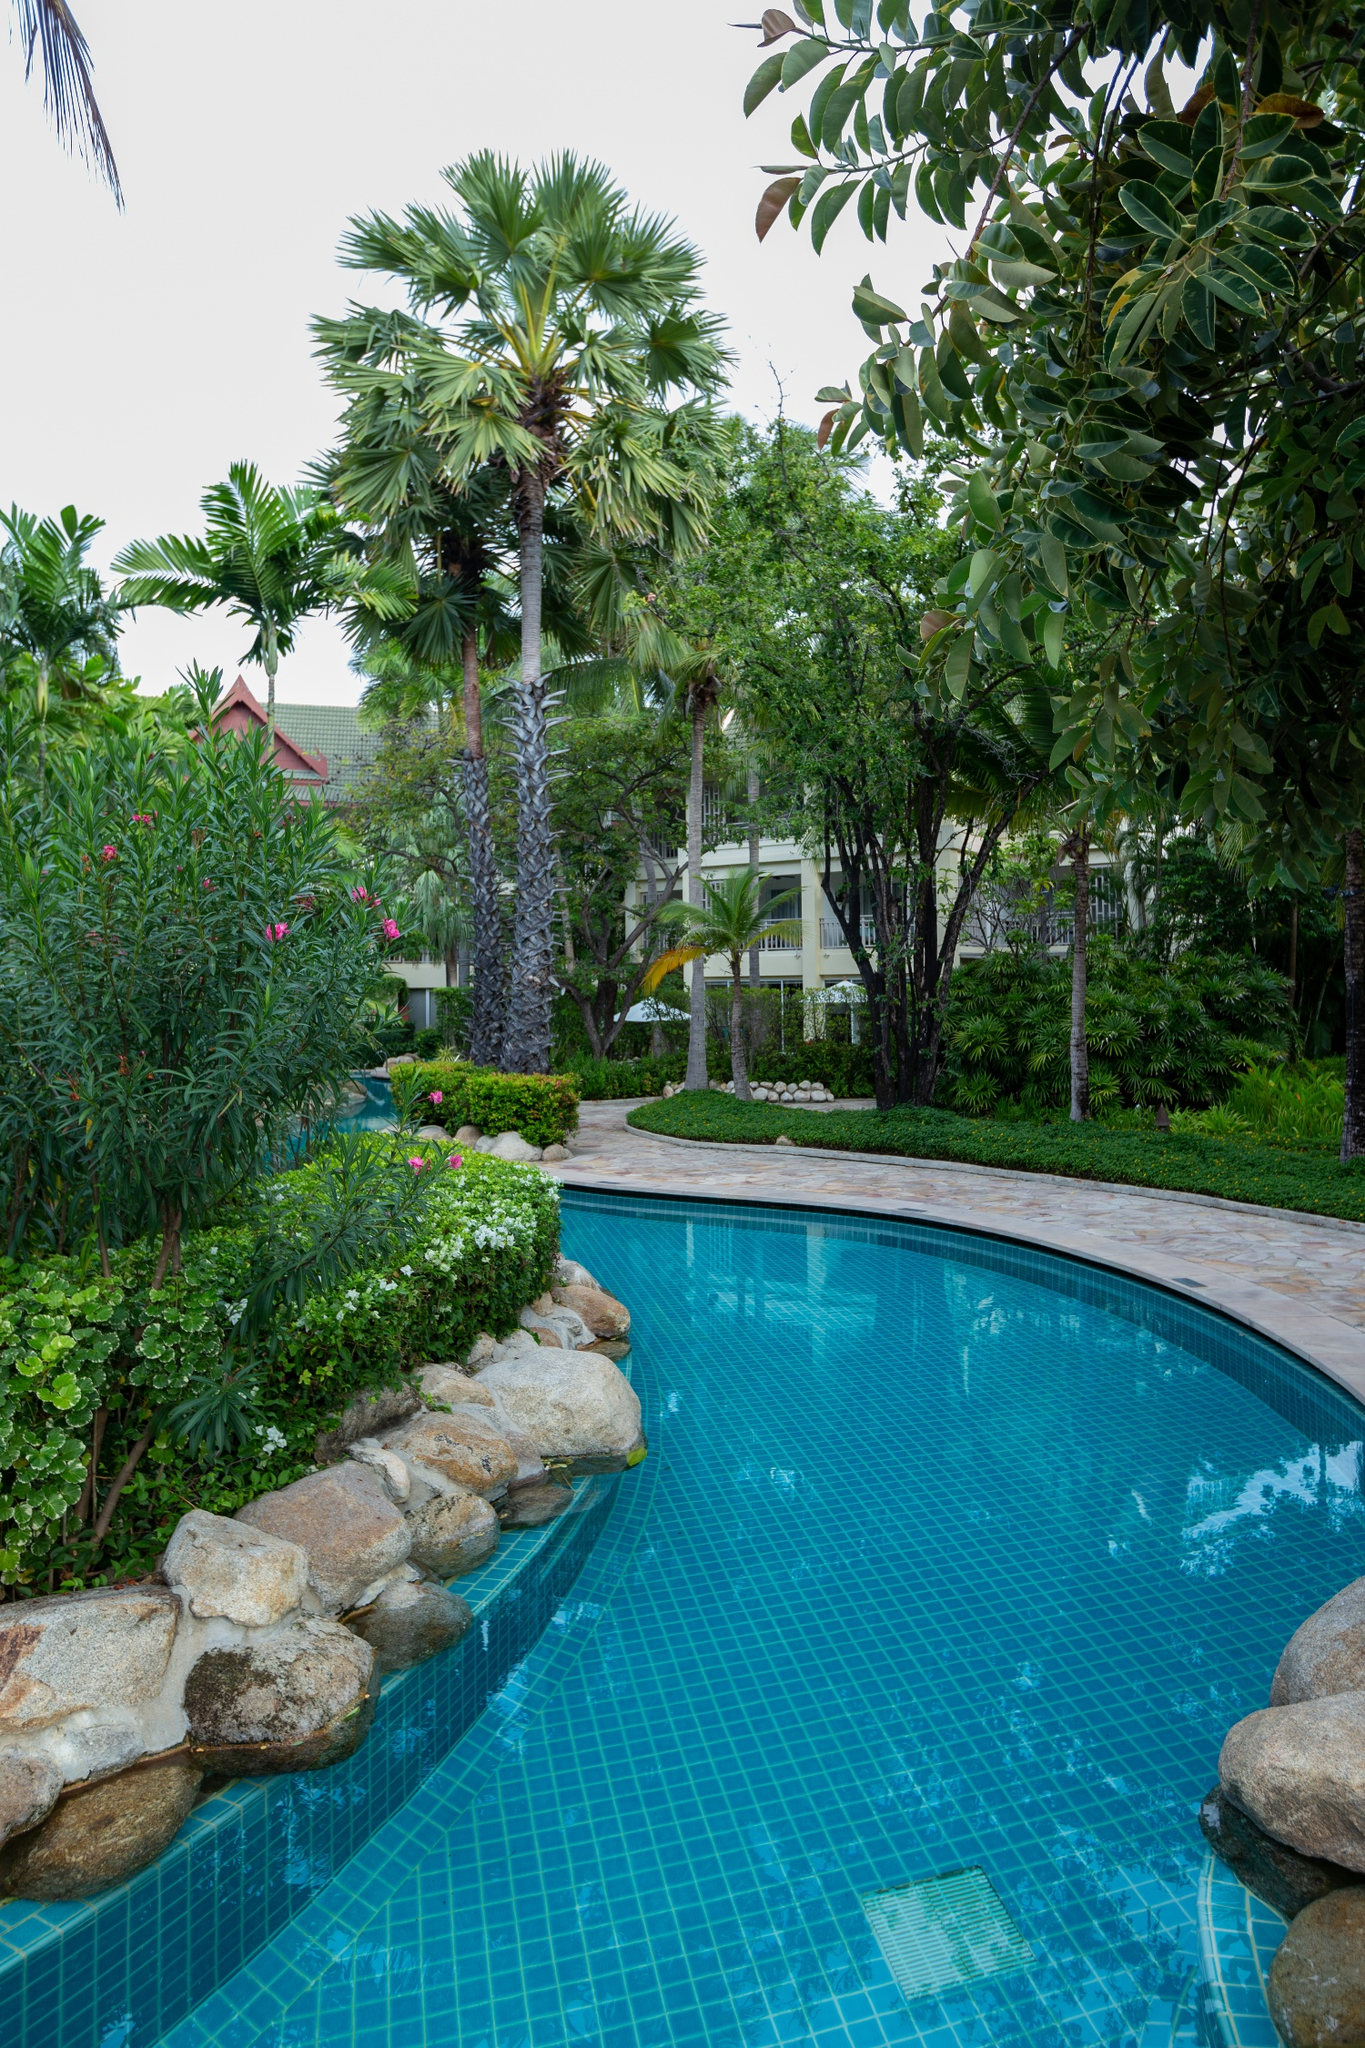Can you craft a creative story based on this image? In a secluded corner of the world, there existed an enchanted garden known only to a select few adventurers. The centerpiece of this magical realm was a pristine, curving swimming pool with waters so clear, they mirrored the sky’s azure hues. Legend had it that the pool was home to a gentle water spirit who blessed the grounds with eternal tranquility and lush greenery. Majestic palm trees whispered secrets of the ancient times, while flowers of every color bloomed vibrantly, fed by the spirit’s nurturing presence. Among the garden’s visitors was Serena, a young explorer with a heart full of dreams. Drawn by tales of the enchanted garden, she embarked on a journey to find it. Upon arrival, Serena felt the warm embrace of peace as the water spirit’s blessings enveloped her. She spent days exploring every nook and cranny of the garden, discovering hidden groves where time seemed to stand still. By night, the white building in the background transformed into a mystical castle, shimmering under the moonlight, revealing Serena’s true quest: to unlock the secret of the enchanted pool. With the spirit’s guidance, she would one day uncover a hidden underwater world brimming with untold stories and adventures, forever changing her destiny. What might the guests enjoy most during an evening at this resort? As the sun begins to set, casting golden hues across the pool and garden, guests at this idyllic resort transition from bustling daytime activities to serene evening indulgences. One of the highlights of the evening is dining al fresco by the poolside, where the gentle sound of water lapping against the rocks accompanies a gourmet meal. As twilight descends, the garden comes alive with the soft glow of lanterns and fairy lights, creating an enchanting ambiance. Guests can savor fine wines and cocktails from the bar, engaging in pleasant conversations or simply soaking in the tranquil surroundings. For those seeking relaxation, an evening swim in the illuminated pool offers a magical experience, with the stars reflecting off the water’s surface. Alternatively, the resort may offer entertainment like live music or cultural performances, giving guests a taste of the local heritage. Ultimately, the evening at this resort is about unwinding in a serene, beautiful setting, creating memories that last a lifetime. 